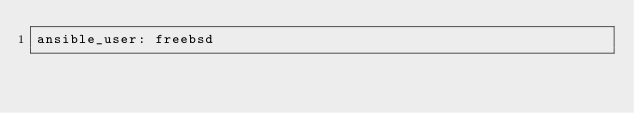Convert code to text. <code><loc_0><loc_0><loc_500><loc_500><_YAML_>ansible_user: freebsd
</code> 